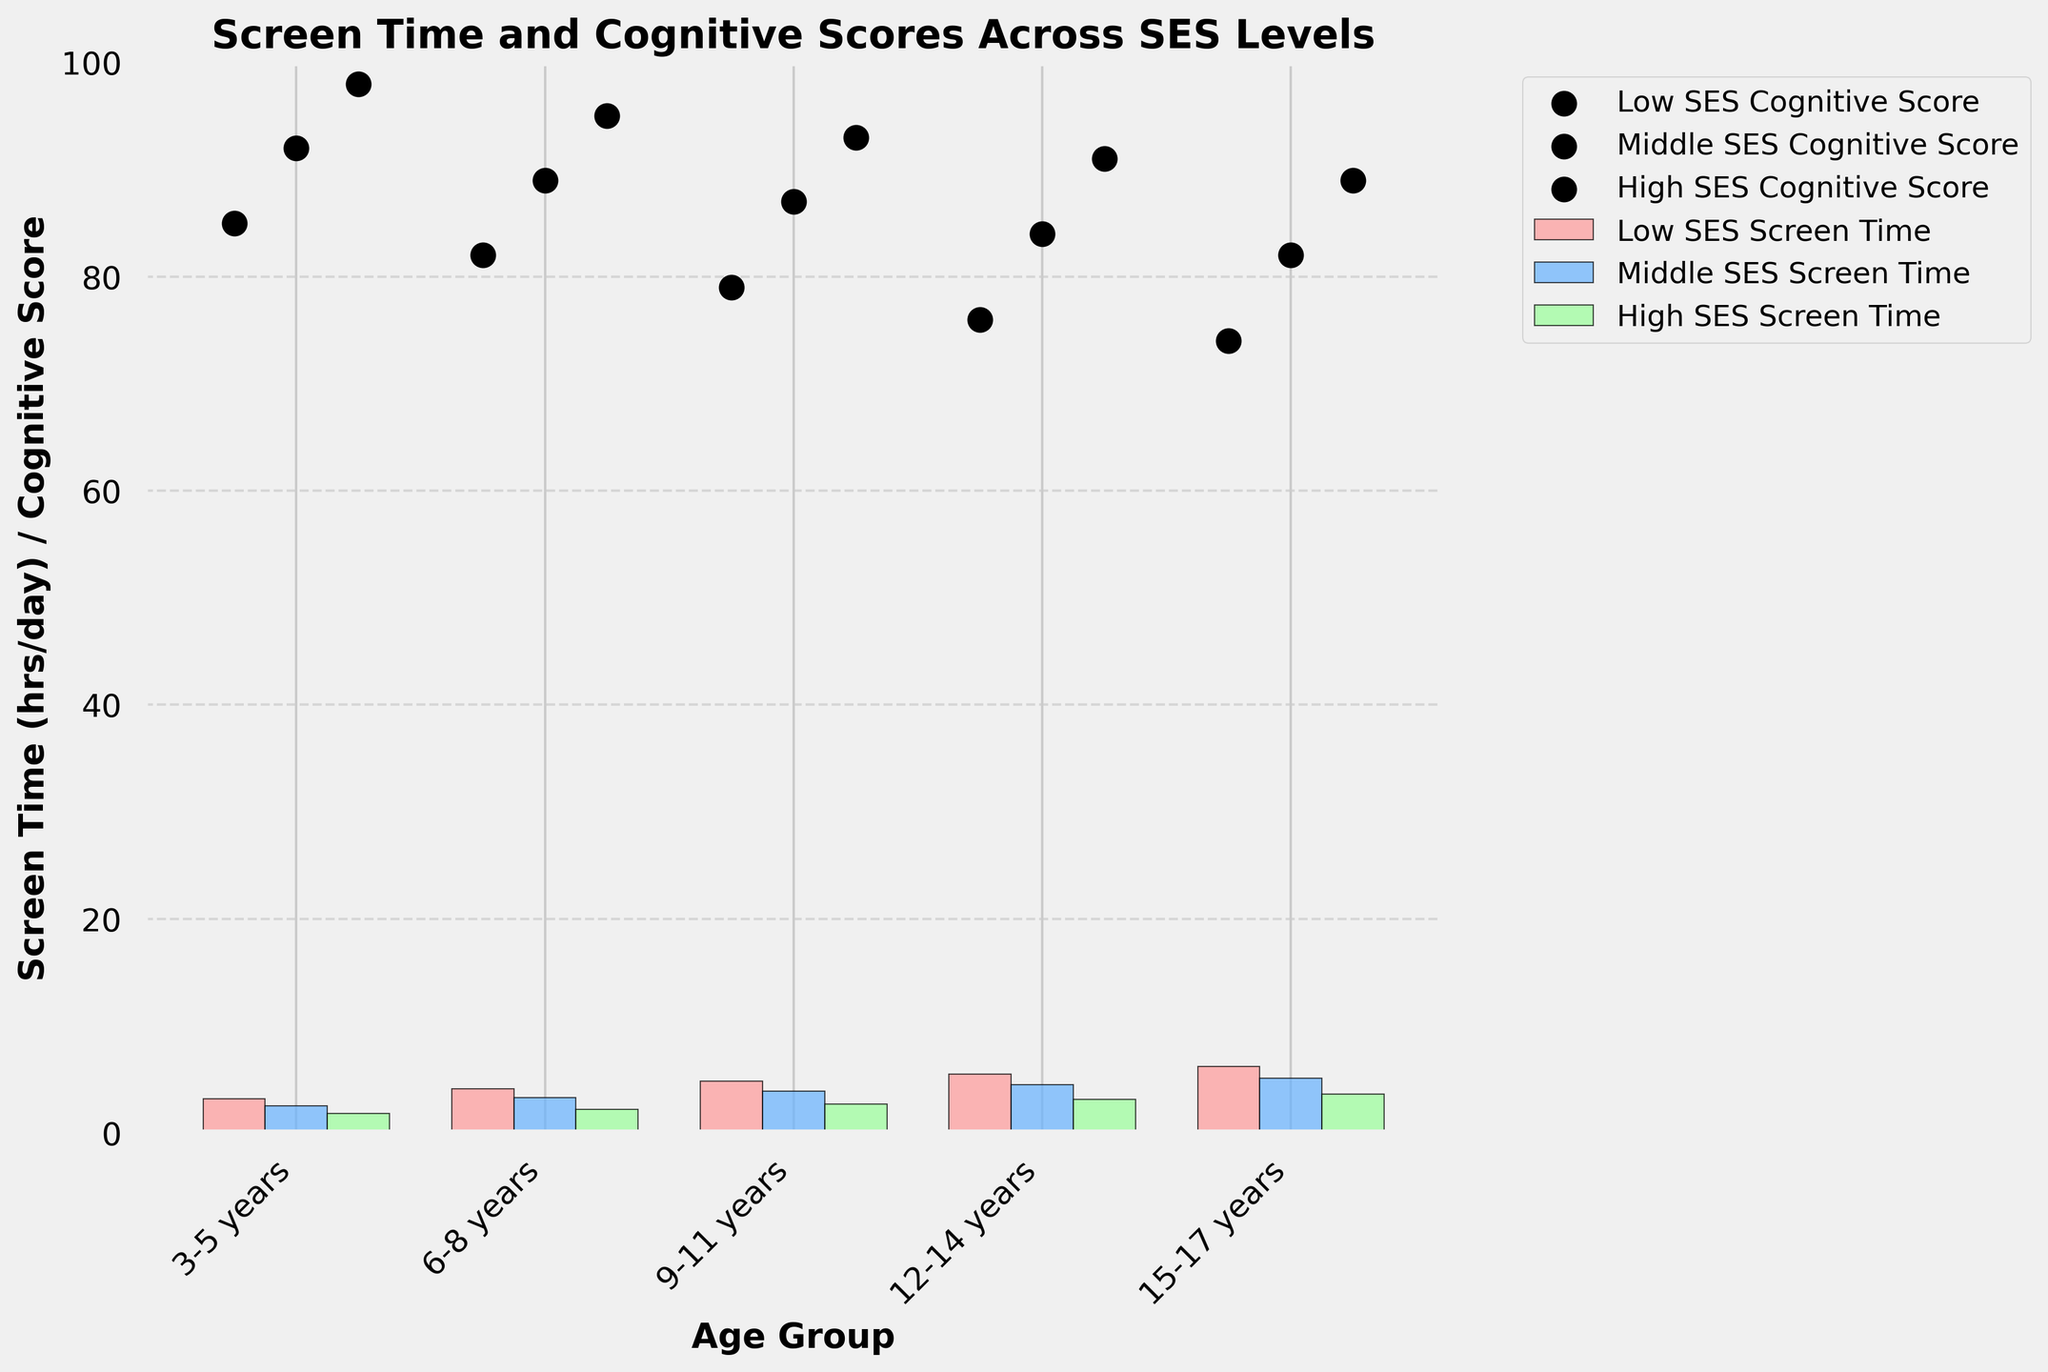Which age group has the highest screen time in the High SES category? The graph shows the bars for screen time. From 3-5 years to 15-17 years, identify the High SES bars and find the tallest one. The 15-17 years group has the tallest bar for High SES.
Answer: 15-17 years What is the difference in cognitive score between the Low SES and High SES groups for 9-11 years? Identify the cognitive score for Low SES and High SES in the 9-11 years group. The Low SES has 79 and High SES has 93. Subtract 79 from 93.
Answer: 14 How does the screen time for Middle SES children change from 6-8 years to 12-14 years? Compare the height of the Middle SES bars from 6-8 years and 12-14 years. The bar for 6-8 years is lower than the bar for 12-14 years.
Answer: Increases Which SES group has the least screen time for the 3-5 years age group? Look at the bars for the 3-5 years age group. The shortest bar among the SES groups is the High SES bar.
Answer: High SES Calculate the average cognitive score for the Middle SES group. Sum up the cognitive scores for Middle SES across all age groups: (92 + 89 + 87 + 84 + 82) = 434. There are 5 age groups, so divide the sum by 5.
Answer: 86.8 In which age group is the cognitive score difference between Low SES and Middle SES the smallest? Calculate the difference in cognitive score for each age group: 3-5 years (92-85=7), 6-8 years (89-82=7), 9-11 years (87-79=8), 12-14 years (84-76=8), 15-17 years (82-74=8). The smallest difference is in the 3-5 years and 6-8 years groups.
Answer: 3-5 years and 6-8 years How many hours of screen time do Low SES children aged 12-14 years spend relative to High SES children of the same age? Compare the height of the bars for screen time in the 12-14 years group between Low SES and High SES. The Low SES bar is much taller than the High SES bar.
Answer: 2.4 hours more Identify the SES group with the highest cognitive score for the 6-8 years age group. Observe the scatter points for the cognitive scores in the 6-8 years group. The highest scatter point is the High SES group at 95.
Answer: High SES What is the total screen time for all SES groups combined in the 15-17 years age group? Sum the screen times of Low SES, Middle SES, and High SES bars for the 15-17 years age group: 6.2 + 5.1 + 3.6 = 14.9.
Answer: 14.9 Between which SES groups is the difference in cognitive score the largest for the age group 12-14 years? Compare the scatter points of cognitive scores for 12-14 years between SES groups. The difference between Low SES (76) and High SES (91) is the largest.
Answer: Low SES and High SES 